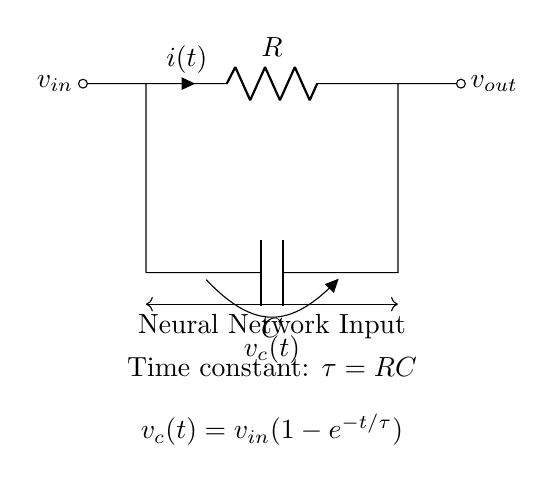What is the time constant in this circuit? The time constant is represented by the formula tau = RC, where R is the resistance and C is the capacitance. The circuit diagram explicitly states this relationship, showing that tau is determined by multiplying the values of R and C.
Answer: tau = RC What is the voltage across the capacitor at infinite time? At infinite time, the capacitor in an RC circuit is fully charged and the voltage across it equals the input voltage, as there is no further change in voltage over time.
Answer: v_c(t) = v_in What will happen to the time constant if the resistance is doubled? If the resistance is doubled, then the time constant tau will also double since tau is directly proportional to R. Therefore, the time constant will increase, resulting in a longer charging time for the capacitor.
Answer: Increased What is the relationship between current and voltage in the circuit? The relationship is defined by Ohm's Law. The current flowing through the resistor can be expressed as I(t) = (v_in - v_c(t)) / R. As the capacitor charges, v_c increases, reducing the current until it approaches zero when fully charged.
Answer: I(t) = (v_in - v_c(t)) / R What does v_c(t) represent in this circuit? v_c(t) represents the voltage across the capacitor as a function of time. The formula given in the diagram indicates that it increases over time according to the equation v_c(t) = v_in(1 - e^(-t/tau)).
Answer: Voltage across the capacitor What effect does increasing capacitance have on the time constant? Increasing the capacitance directly increases the time constant tau, since tau = RC. A larger capacitance means that the capacitor can store more charge, which slows down the charging process, causing an increase in the time constant.
Answer: Increased 